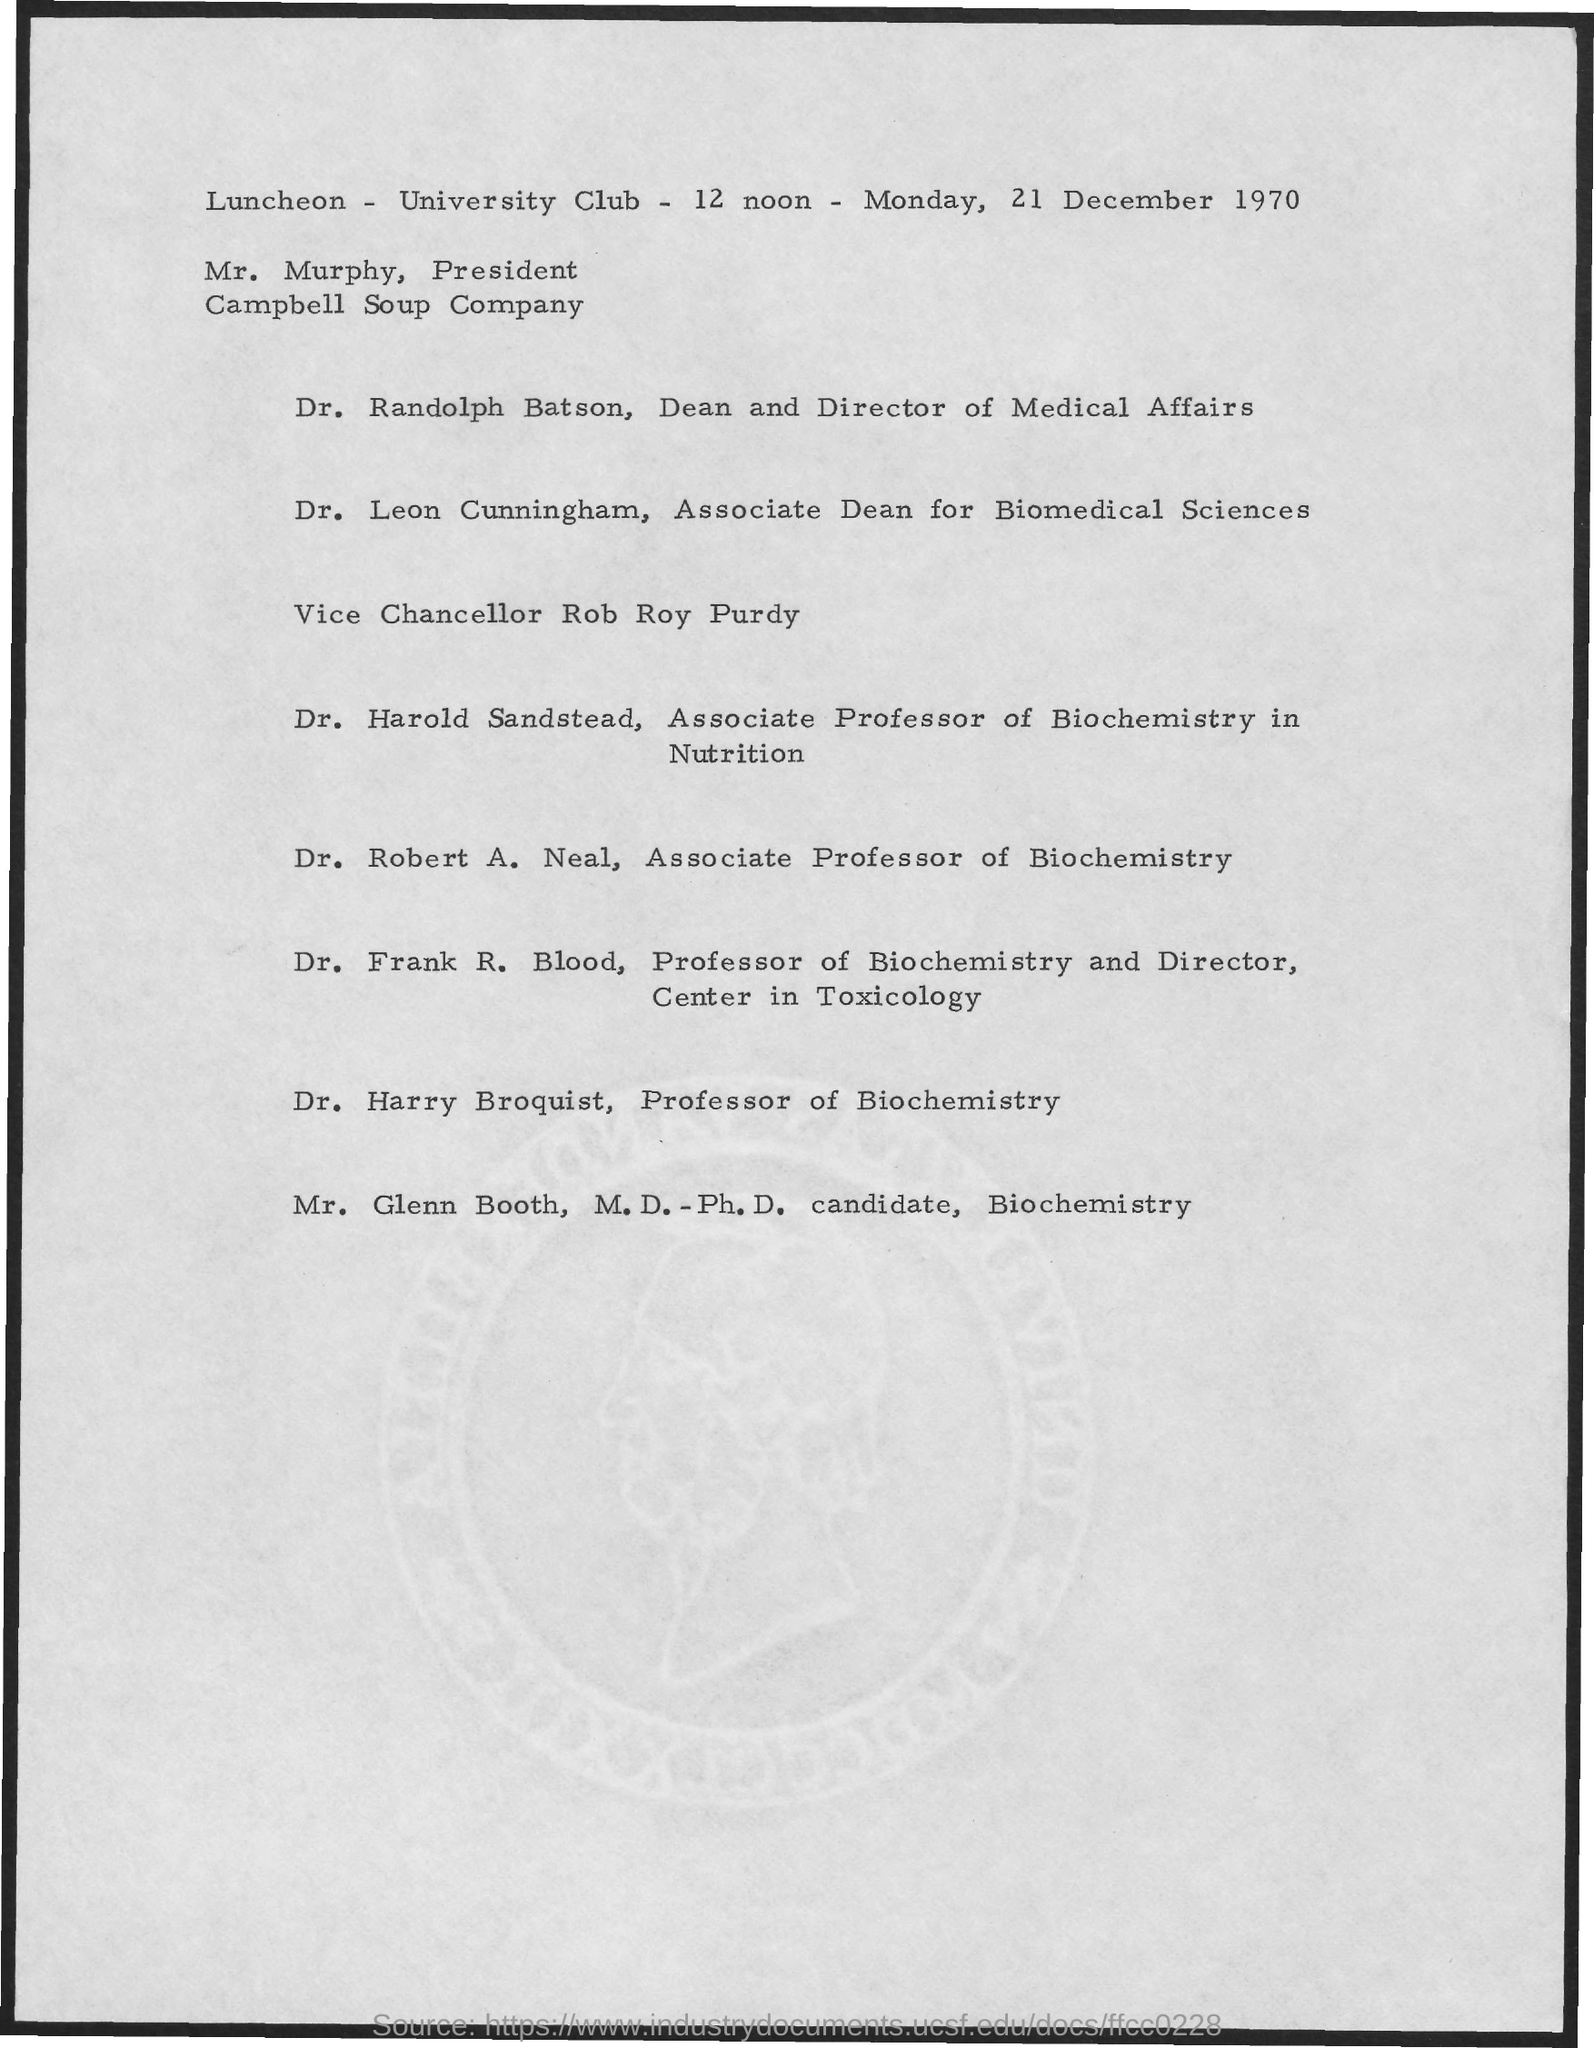Point out several critical features in this image. The date mentioned is Monday, December 21, 1970. Dr. Randolph Batson is the Dean and Director of Medical Affairs. 